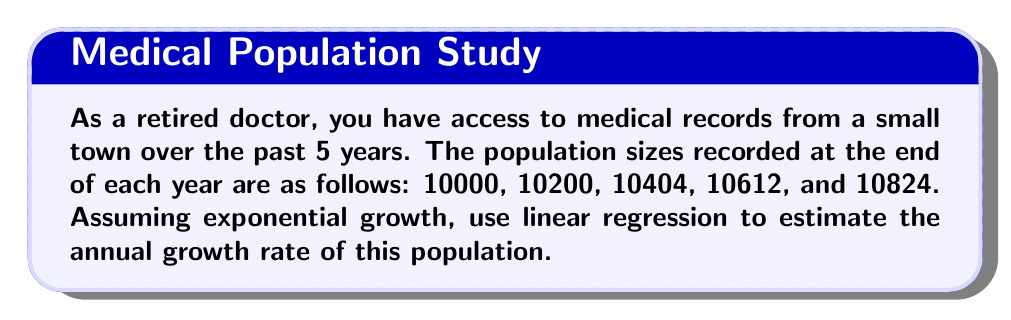Can you solve this math problem? To solve this problem, we'll use the exponential growth model and apply linear regression:

1) The exponential growth model is given by:
   $$P(t) = P_0e^{rt}$$
   where $P(t)$ is the population at time $t$, $P_0$ is the initial population, $r$ is the growth rate, and $t$ is time.

2) Taking the natural logarithm of both sides:
   $$\ln(P(t)) = \ln(P_0) + rt$$

3) This is now in the form of a linear equation $y = mx + b$, where:
   $y = \ln(P(t))$, $m = r$, $x = t$, and $b = \ln(P_0)$

4) We'll create a table with $t$ and $\ln(P(t))$:

   | t | P(t)  | ln(P(t)) |
   |---|-------|----------|
   | 0 | 10000 | 9.2103   |
   | 1 | 10200 | 9.2302   |
   | 2 | 10404 | 9.2500   |
   | 3 | 10612 | 9.2697   |
   | 4 | 10824 | 9.2893   |

5) For linear regression, we need to calculate:
   $$r = \frac{n\sum(xy) - \sum x \sum y}{n\sum x^2 - (\sum x)^2}$$

   Where $n = 5$, $x = t$, and $y = \ln(P(t))$

6) Calculating the sums:
   $\sum x = 10$
   $\sum y = 46.2495$
   $\sum xy = 92.9780$
   $\sum x^2 = 30$

7) Plugging into the formula:
   $$r = \frac{5(92.9780) - 10(46.2495)}{5(30) - 10^2} = 0.0198$$

8) Convert to a percentage: $0.0198 * 100 = 1.98\%$
Answer: 1.98% 